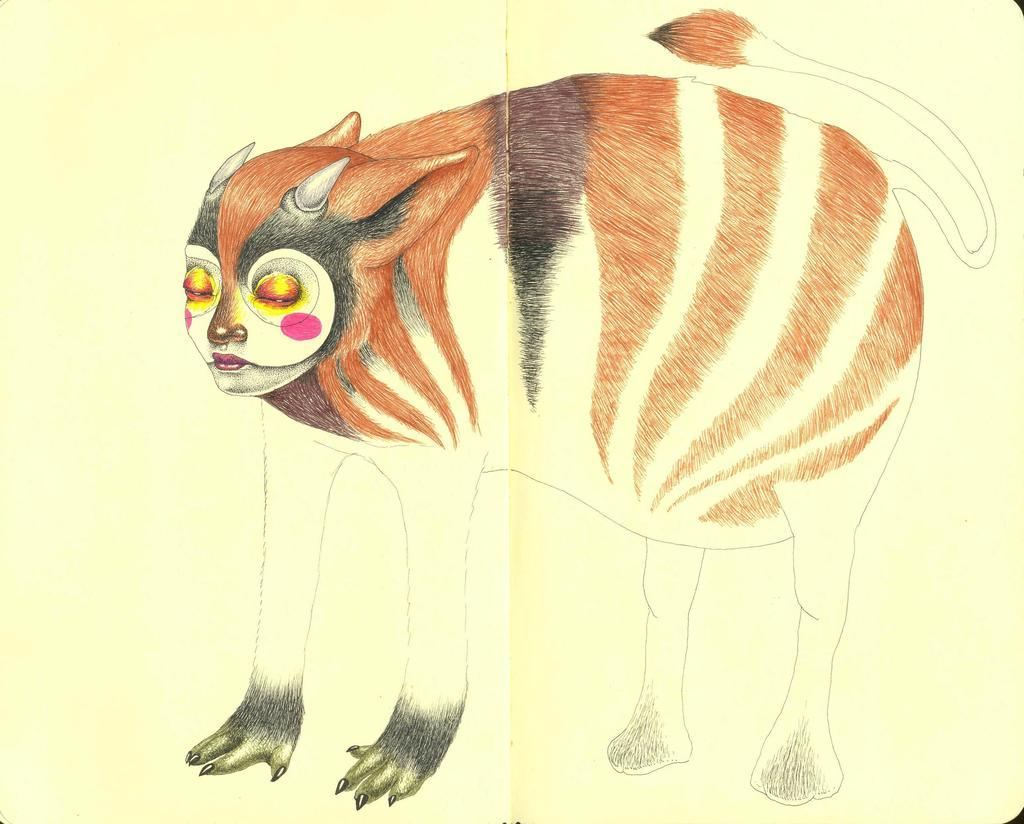What is the medium of the image? The image is on a paper. What is depicted in the image? There is a sketch of an animal on the paper. How many birds are flying in a low flock in the image? There are no birds present in the image; it features a sketch of an animal. 